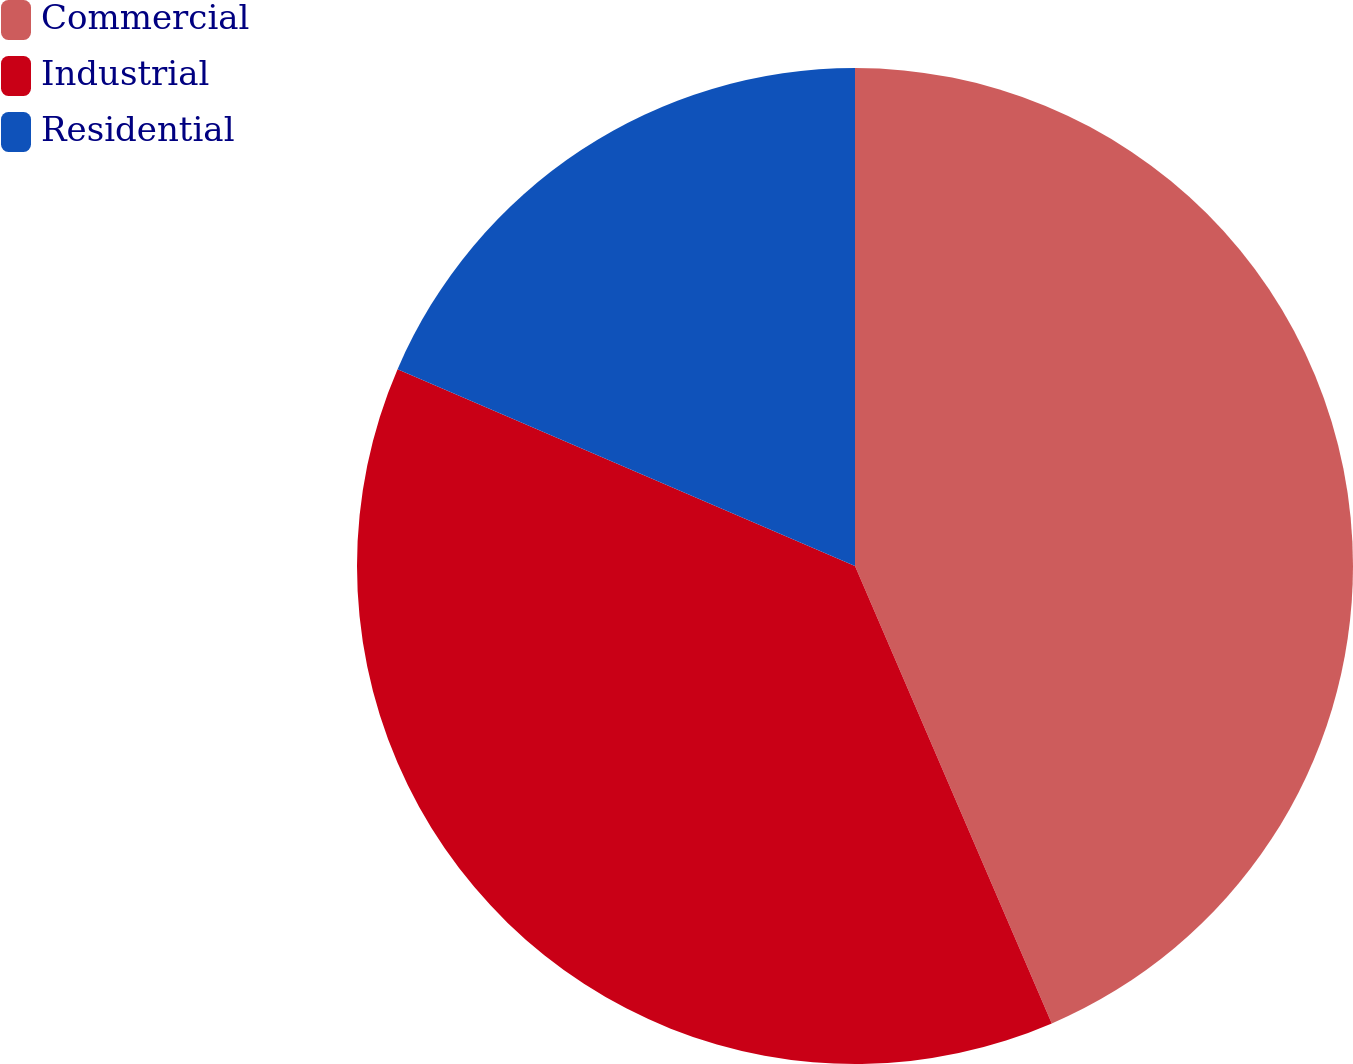<chart> <loc_0><loc_0><loc_500><loc_500><pie_chart><fcel>Commercial<fcel>Industrial<fcel>Residential<nl><fcel>43.53%<fcel>37.93%<fcel>18.53%<nl></chart> 